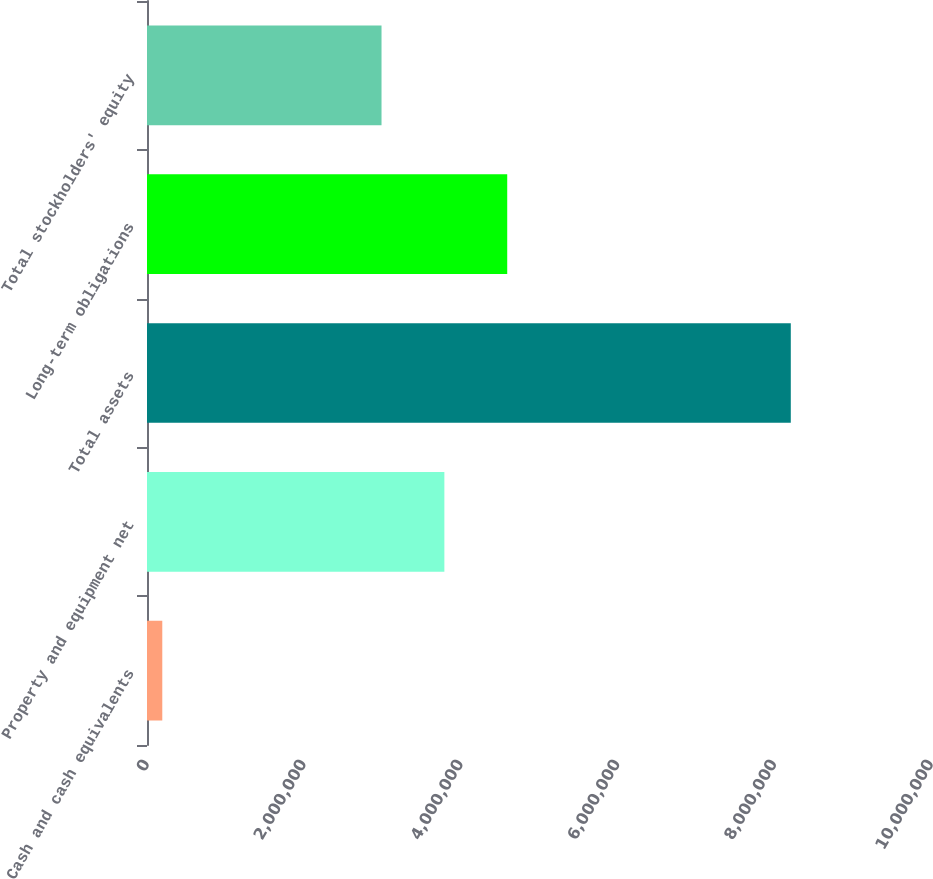Convert chart to OTSL. <chart><loc_0><loc_0><loc_500><loc_500><bar_chart><fcel>Cash and cash equivalents<fcel>Property and equipment net<fcel>Total assets<fcel>Long-term obligations<fcel>Total stockholders' equity<nl><fcel>194943<fcel>3.79299e+06<fcel>8.21166e+06<fcel>4.59467e+06<fcel>2.99132e+06<nl></chart> 